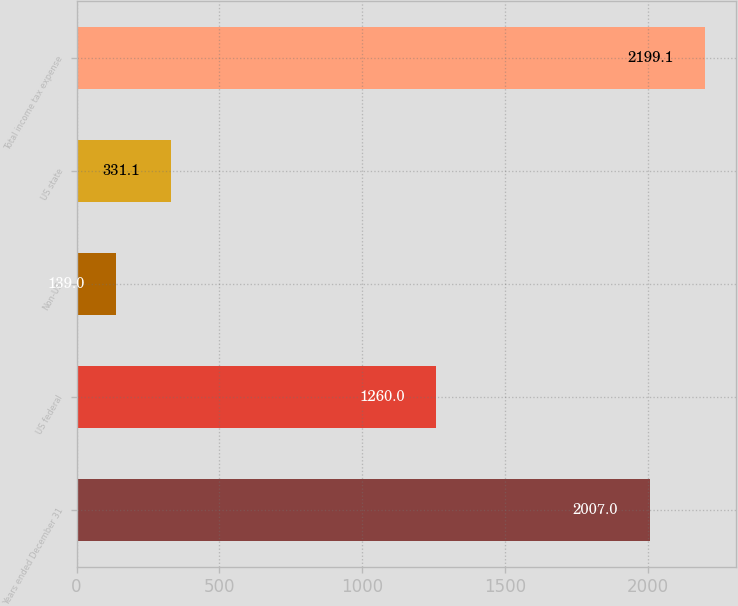Convert chart to OTSL. <chart><loc_0><loc_0><loc_500><loc_500><bar_chart><fcel>Years ended December 31<fcel>US federal<fcel>Non-US<fcel>US state<fcel>Total income tax expense<nl><fcel>2007<fcel>1260<fcel>139<fcel>331.1<fcel>2199.1<nl></chart> 